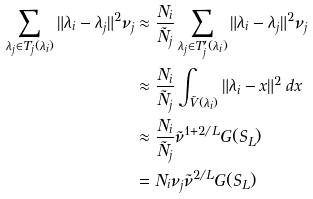Convert formula to latex. <formula><loc_0><loc_0><loc_500><loc_500>\sum _ { \lambda _ { j } \in T _ { j } ( \lambda _ { i } ) } \| \lambda _ { i } - \lambda _ { j } \| ^ { 2 } \nu _ { j } & \approx \frac { N _ { i } } { \tilde { N } _ { j } } \sum _ { \lambda _ { j } \in T ^ { \prime } _ { j } ( \lambda _ { i } ) } \| \lambda _ { i } - \lambda _ { j } \| ^ { 2 } \nu _ { j } \\ & \approx \frac { N _ { i } } { \tilde { N } _ { j } } \int _ { \tilde { V } ( \lambda _ { i } ) } \| \lambda _ { i } - x \| ^ { 2 } \, d x \\ & \approx \frac { N _ { i } } { \tilde { N } _ { j } } \tilde { \nu } ^ { 1 + 2 / L } G ( S _ { L } ) \\ & = N _ { i } \nu _ { j } \tilde { \nu } ^ { 2 / L } G ( S _ { L } ) \\</formula> 